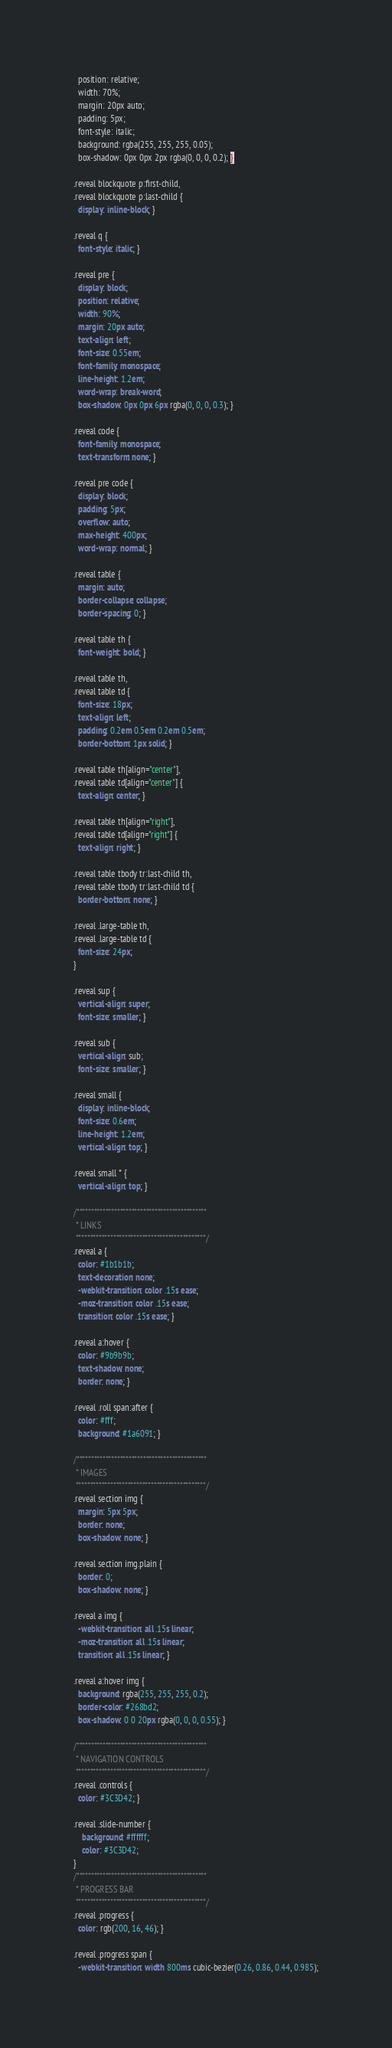Convert code to text. <code><loc_0><loc_0><loc_500><loc_500><_CSS_>  position: relative;
  width: 70%;
  margin: 20px auto;
  padding: 5px;
  font-style: italic;
  background: rgba(255, 255, 255, 0.05);
  box-shadow: 0px 0px 2px rgba(0, 0, 0, 0.2); }

.reveal blockquote p:first-child,
.reveal blockquote p:last-child {
  display: inline-block; }

.reveal q {
  font-style: italic; }

.reveal pre {
  display: block;
  position: relative;
  width: 90%;
  margin: 20px auto;
  text-align: left;
  font-size: 0.55em;
  font-family: monospace;
  line-height: 1.2em;
  word-wrap: break-word;
  box-shadow: 0px 0px 6px rgba(0, 0, 0, 0.3); }

.reveal code {
  font-family: monospace;
  text-transform: none; }

.reveal pre code {
  display: block;
  padding: 5px;
  overflow: auto;
  max-height: 400px;
  word-wrap: normal; }

.reveal table {
  margin: auto;
  border-collapse: collapse;
  border-spacing: 0; }

.reveal table th {
  font-weight: bold; }

.reveal table th,
.reveal table td {
  font-size: 18px;
  text-align: left;
  padding: 0.2em 0.5em 0.2em 0.5em;
  border-bottom: 1px solid; }

.reveal table th[align="center"],
.reveal table td[align="center"] {
  text-align: center; }

.reveal table th[align="right"],
.reveal table td[align="right"] {
  text-align: right; }

.reveal table tbody tr:last-child th,
.reveal table tbody tr:last-child td {
  border-bottom: none; }

.reveal .large-table th,
.reveal .large-table td {
  font-size: 24px;
}

.reveal sup {
  vertical-align: super;
  font-size: smaller; }

.reveal sub {
  vertical-align: sub;
  font-size: smaller; }

.reveal small {
  display: inline-block;
  font-size: 0.6em;
  line-height: 1.2em;
  vertical-align: top; }

.reveal small * {
  vertical-align: top; }

/*********************************************
 * LINKS
 *********************************************/
.reveal a {
  color: #1b1b1b;
  text-decoration: none;
  -webkit-transition: color .15s ease;
  -moz-transition: color .15s ease;
  transition: color .15s ease; }

.reveal a:hover {
  color: #9b9b9b;
  text-shadow: none;
  border: none; }

.reveal .roll span:after {
  color: #fff;
  background: #1a6091; }

/*********************************************
 * IMAGES
 *********************************************/
.reveal section img {
  margin: 5px 5px;
  border: none;
  box-shadow: none; }

.reveal section img.plain {
  border: 0;
  box-shadow: none; }

.reveal a img {
  -webkit-transition: all .15s linear;
  -moz-transition: all .15s linear;
  transition: all .15s linear; }

.reveal a:hover img {
  background: rgba(255, 255, 255, 0.2);
  border-color: #268bd2;
  box-shadow: 0 0 20px rgba(0, 0, 0, 0.55); }

/*********************************************
 * NAVIGATION CONTROLS
 *********************************************/
.reveal .controls {
  color: #3C3D42; }

.reveal .slide-number {
	background: #ffffff;
	color: #3C3D42;
}
/*********************************************
 * PROGRESS BAR
 *********************************************/
.reveal .progress {
  color: rgb(200, 16, 46); }

.reveal .progress span {
  -webkit-transition: width 800ms cubic-bezier(0.26, 0.86, 0.44, 0.985);</code> 